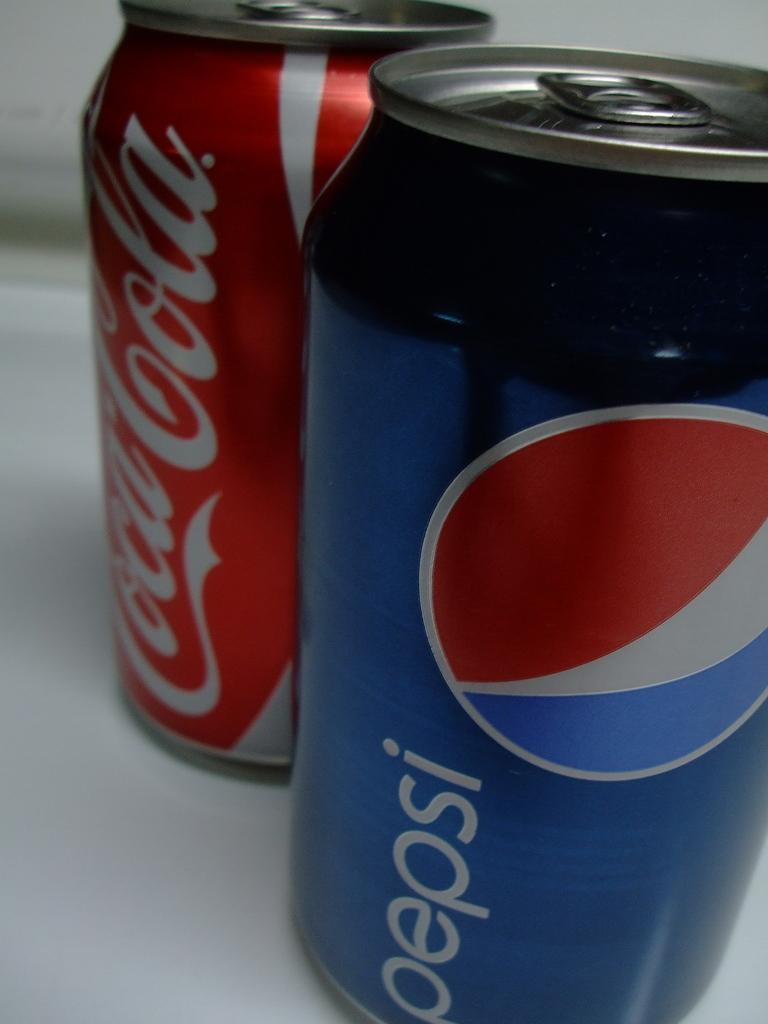Provide a one-sentence caption for the provided image. A can of coca cola is behind a can of pepsi. 